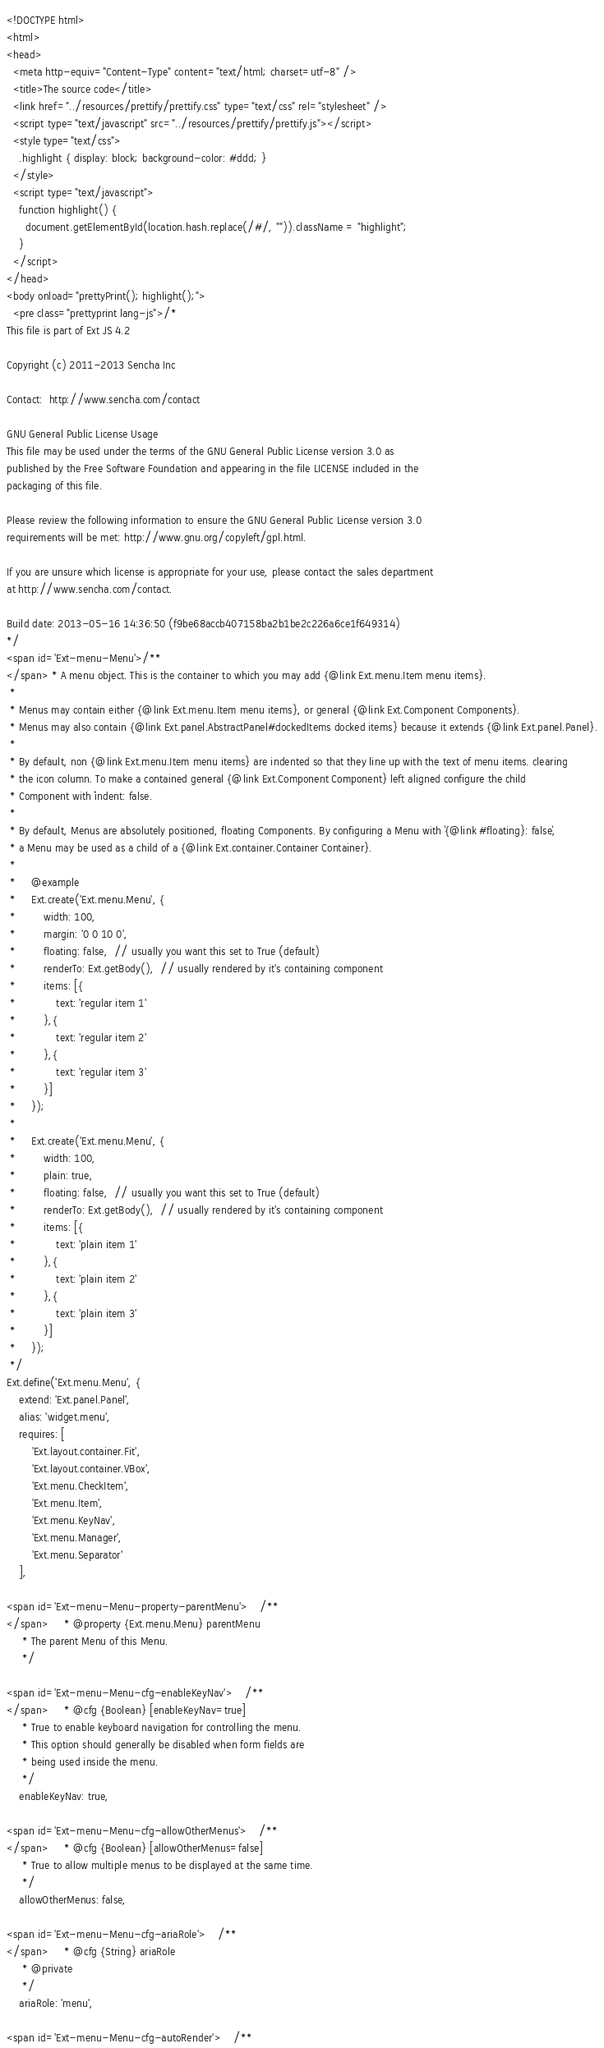Convert code to text. <code><loc_0><loc_0><loc_500><loc_500><_HTML_><!DOCTYPE html>
<html>
<head>
  <meta http-equiv="Content-Type" content="text/html; charset=utf-8" />
  <title>The source code</title>
  <link href="../resources/prettify/prettify.css" type="text/css" rel="stylesheet" />
  <script type="text/javascript" src="../resources/prettify/prettify.js"></script>
  <style type="text/css">
    .highlight { display: block; background-color: #ddd; }
  </style>
  <script type="text/javascript">
    function highlight() {
      document.getElementById(location.hash.replace(/#/, "")).className = "highlight";
    }
  </script>
</head>
<body onload="prettyPrint(); highlight();">
  <pre class="prettyprint lang-js">/*
This file is part of Ext JS 4.2

Copyright (c) 2011-2013 Sencha Inc

Contact:  http://www.sencha.com/contact

GNU General Public License Usage
This file may be used under the terms of the GNU General Public License version 3.0 as
published by the Free Software Foundation and appearing in the file LICENSE included in the
packaging of this file.

Please review the following information to ensure the GNU General Public License version 3.0
requirements will be met: http://www.gnu.org/copyleft/gpl.html.

If you are unsure which license is appropriate for your use, please contact the sales department
at http://www.sencha.com/contact.

Build date: 2013-05-16 14:36:50 (f9be68accb407158ba2b1be2c226a6ce1f649314)
*/
<span id='Ext-menu-Menu'>/**
</span> * A menu object. This is the container to which you may add {@link Ext.menu.Item menu items}.
 *
 * Menus may contain either {@link Ext.menu.Item menu items}, or general {@link Ext.Component Components}.
 * Menus may also contain {@link Ext.panel.AbstractPanel#dockedItems docked items} because it extends {@link Ext.panel.Panel}.
 *
 * By default, non {@link Ext.menu.Item menu items} are indented so that they line up with the text of menu items. clearing
 * the icon column. To make a contained general {@link Ext.Component Component} left aligned configure the child
 * Component with `indent: false.
 *
 * By default, Menus are absolutely positioned, floating Components. By configuring a Menu with `{@link #floating}: false`,
 * a Menu may be used as a child of a {@link Ext.container.Container Container}.
 *
 *     @example
 *     Ext.create('Ext.menu.Menu', {
 *         width: 100,
 *         margin: '0 0 10 0',
 *         floating: false,  // usually you want this set to True (default)
 *         renderTo: Ext.getBody(),  // usually rendered by it's containing component
 *         items: [{
 *             text: 'regular item 1'
 *         },{
 *             text: 'regular item 2'
 *         },{
 *             text: 'regular item 3'
 *         }]
 *     });
 *
 *     Ext.create('Ext.menu.Menu', {
 *         width: 100,
 *         plain: true,
 *         floating: false,  // usually you want this set to True (default)
 *         renderTo: Ext.getBody(),  // usually rendered by it's containing component
 *         items: [{
 *             text: 'plain item 1'
 *         },{
 *             text: 'plain item 2'
 *         },{
 *             text: 'plain item 3'
 *         }]
 *     });
 */
Ext.define('Ext.menu.Menu', {
    extend: 'Ext.panel.Panel',
    alias: 'widget.menu',
    requires: [
        'Ext.layout.container.Fit',
        'Ext.layout.container.VBox',
        'Ext.menu.CheckItem',
        'Ext.menu.Item',
        'Ext.menu.KeyNav',
        'Ext.menu.Manager',
        'Ext.menu.Separator'
    ],

<span id='Ext-menu-Menu-property-parentMenu'>    /**
</span>     * @property {Ext.menu.Menu} parentMenu
     * The parent Menu of this Menu.
     */
    
<span id='Ext-menu-Menu-cfg-enableKeyNav'>    /**
</span>     * @cfg {Boolean} [enableKeyNav=true]
     * True to enable keyboard navigation for controlling the menu.
     * This option should generally be disabled when form fields are
     * being used inside the menu.
     */
    enableKeyNav: true,

<span id='Ext-menu-Menu-cfg-allowOtherMenus'>    /**
</span>     * @cfg {Boolean} [allowOtherMenus=false]
     * True to allow multiple menus to be displayed at the same time.
     */
    allowOtherMenus: false,

<span id='Ext-menu-Menu-cfg-ariaRole'>    /**
</span>     * @cfg {String} ariaRole
     * @private
     */
    ariaRole: 'menu',

<span id='Ext-menu-Menu-cfg-autoRender'>    /**</code> 